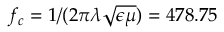Convert formula to latex. <formula><loc_0><loc_0><loc_500><loc_500>f _ { c } = 1 / ( 2 \pi \lambda \sqrt { \epsilon \mu } ) = 4 7 8 . 7 5</formula> 